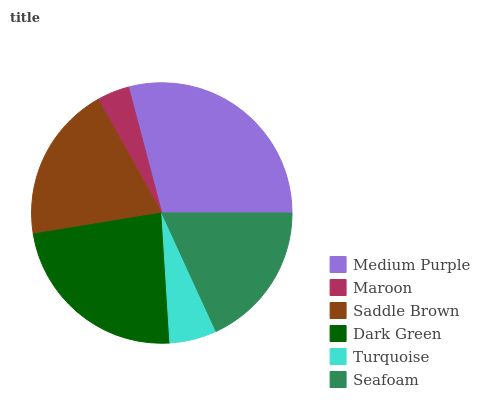Is Maroon the minimum?
Answer yes or no. Yes. Is Medium Purple the maximum?
Answer yes or no. Yes. Is Saddle Brown the minimum?
Answer yes or no. No. Is Saddle Brown the maximum?
Answer yes or no. No. Is Saddle Brown greater than Maroon?
Answer yes or no. Yes. Is Maroon less than Saddle Brown?
Answer yes or no. Yes. Is Maroon greater than Saddle Brown?
Answer yes or no. No. Is Saddle Brown less than Maroon?
Answer yes or no. No. Is Saddle Brown the high median?
Answer yes or no. Yes. Is Seafoam the low median?
Answer yes or no. Yes. Is Turquoise the high median?
Answer yes or no. No. Is Maroon the low median?
Answer yes or no. No. 